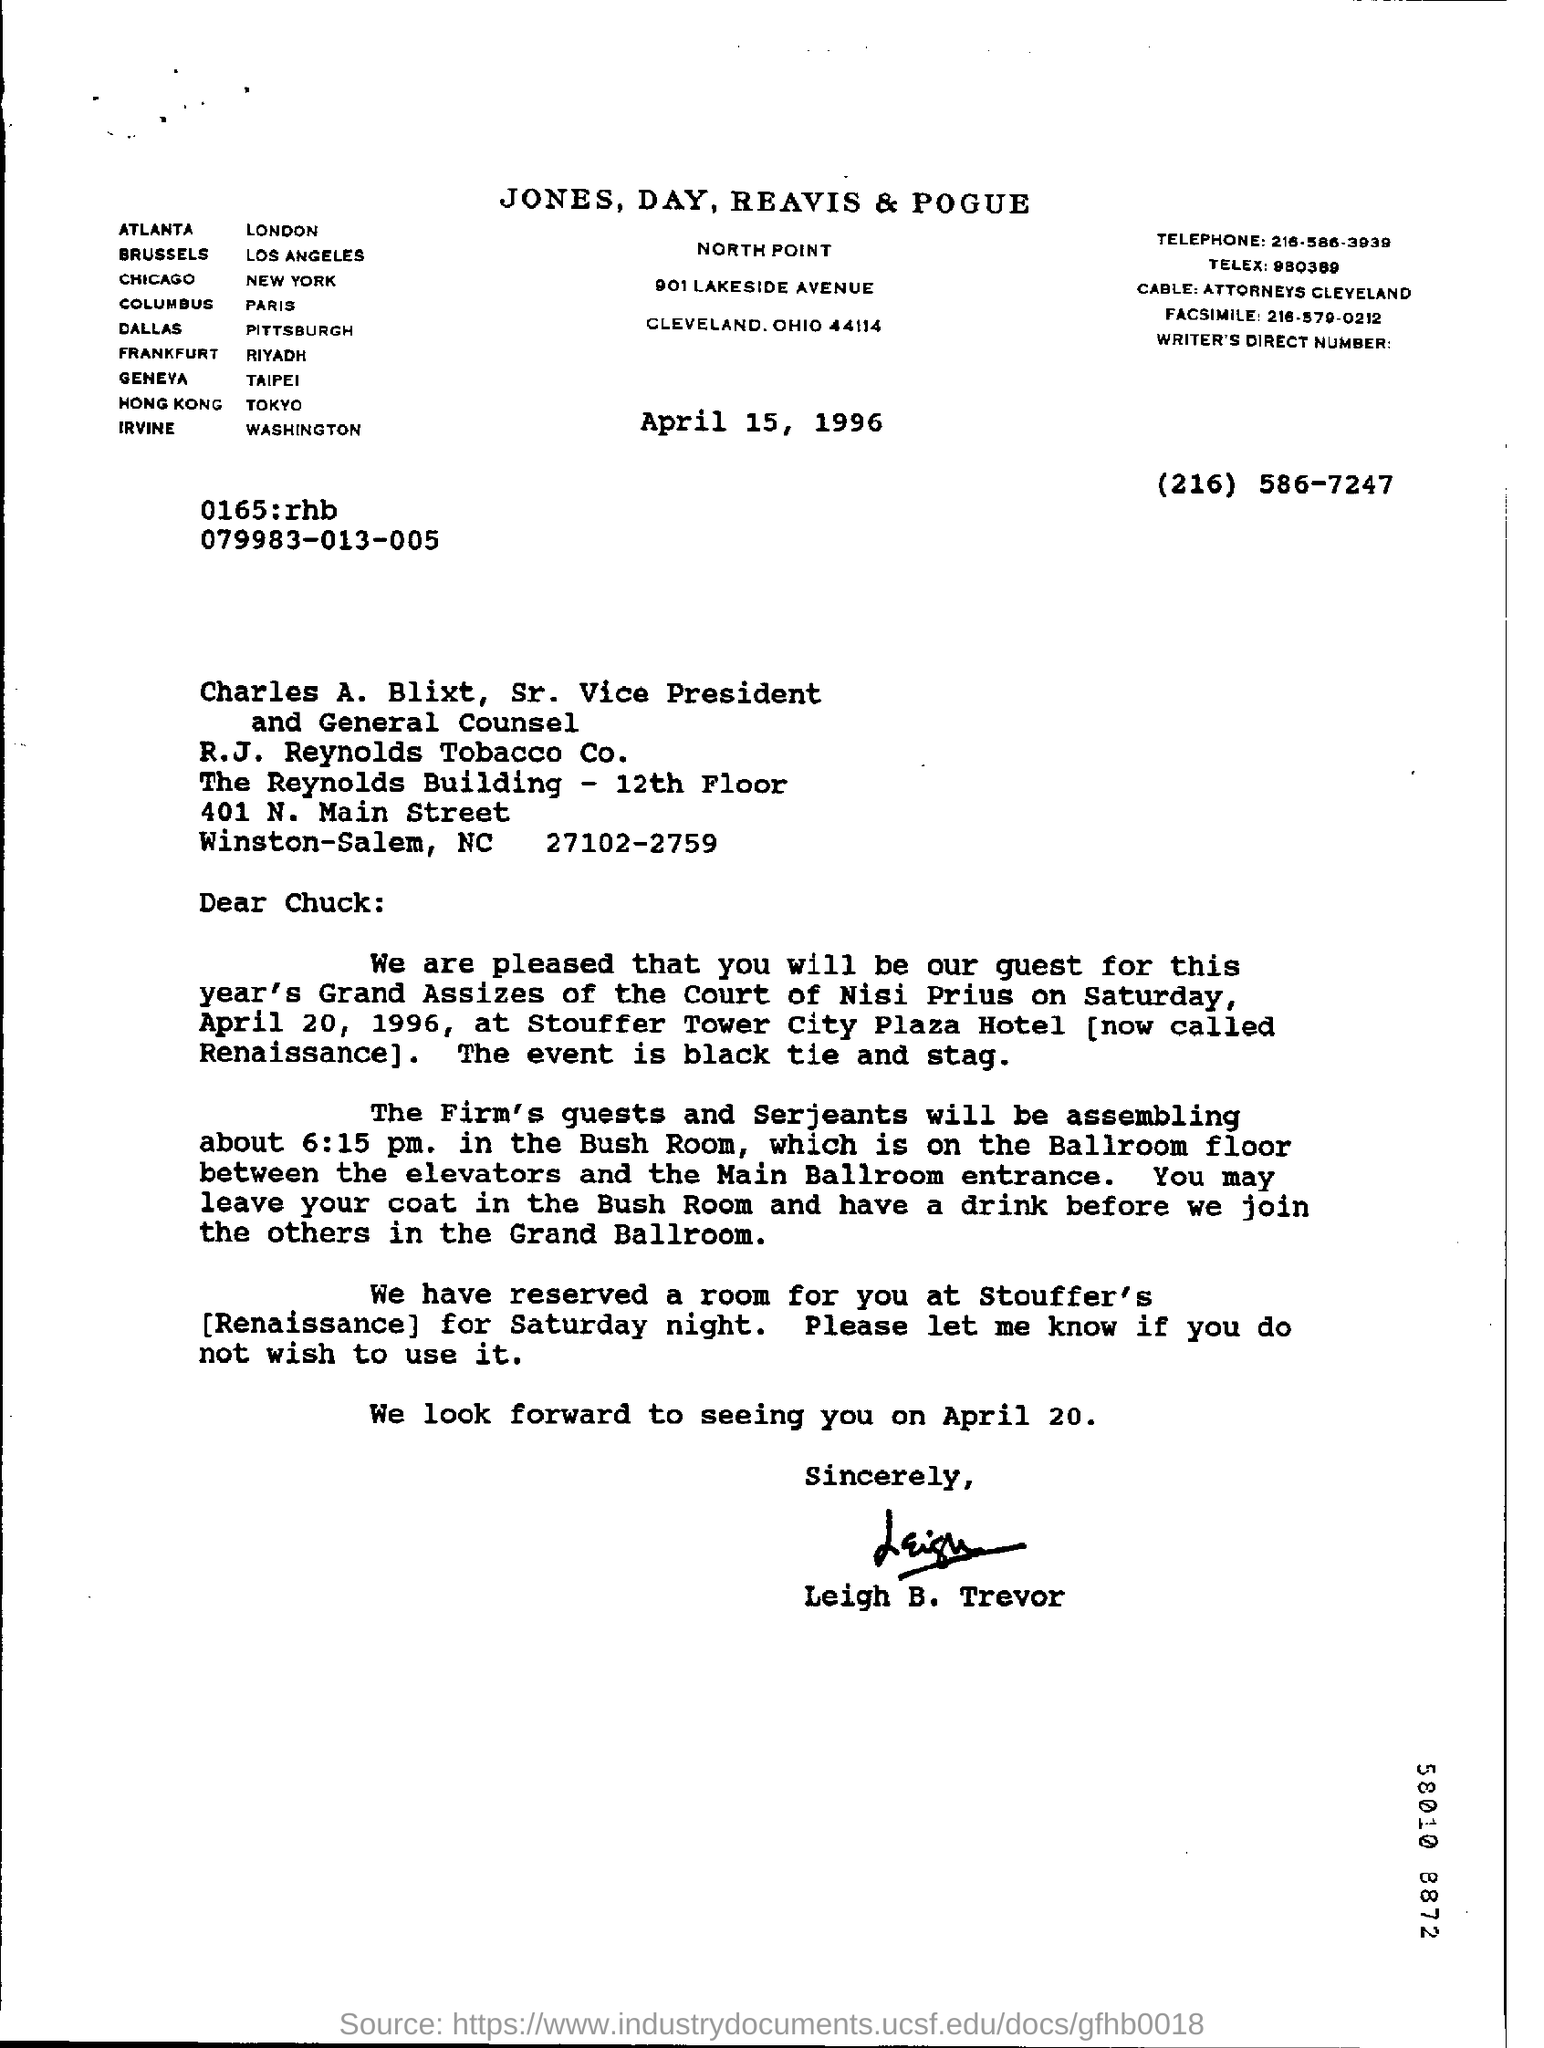What is the salutation of this letter?
Your response must be concise. Dear chuck:. 